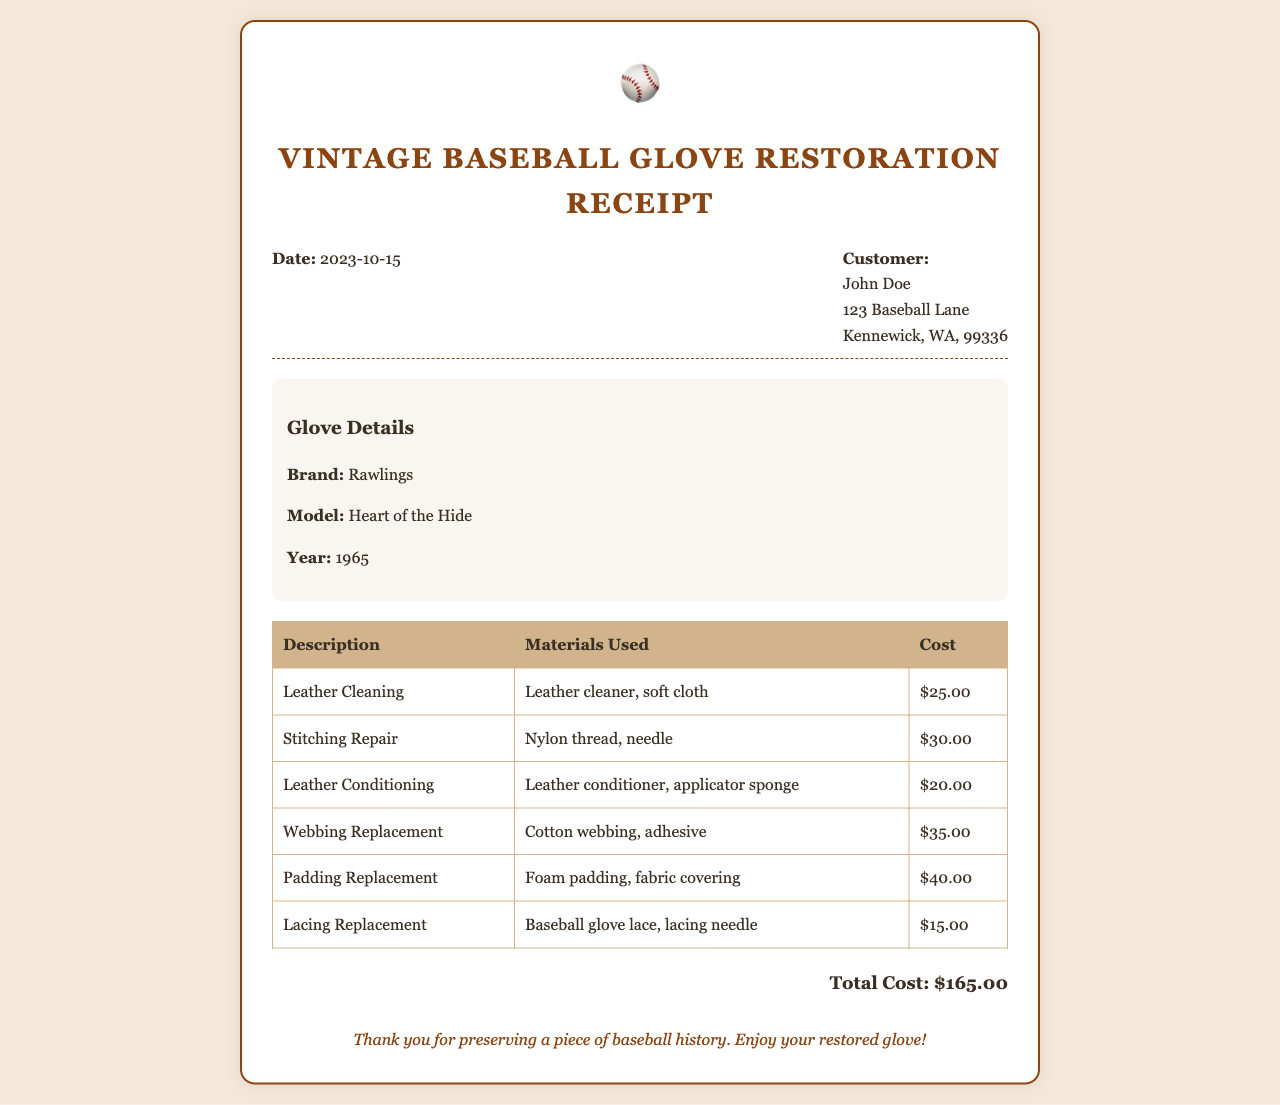What is the date of the receipt? The date of the receipt is found in the header section.
Answer: 2023-10-15 Who is the customer? The customer's name and address are listed in the header section.
Answer: John Doe What is the brand of the glove? The brand of the glove is mentioned under the glove details section.
Answer: Rawlings How much does leather conditioning cost? The cost of leather conditioning is provided in the itemized table.
Answer: $20.00 What materials were used for stitching repair? The materials used for stitching repair are listed in the itemized table next to the corresponding service.
Answer: Nylon thread, needle What is the total cost of the restoration? The total cost is displayed at the bottom of the receipt after the itemized charges.
Answer: $165.00 How many types of repairs were listed? The number of types of repairs can be counted from the rows in the itemized table.
Answer: 6 What year is the glove from? The year of the glove is stated in the glove details section.
Answer: 1965 What is the last note on the receipt? The last note expressed thanks to the customer and is found at the bottom of the receipt.
Answer: Thank you for preserving a piece of baseball history. Enjoy your restored glove! 